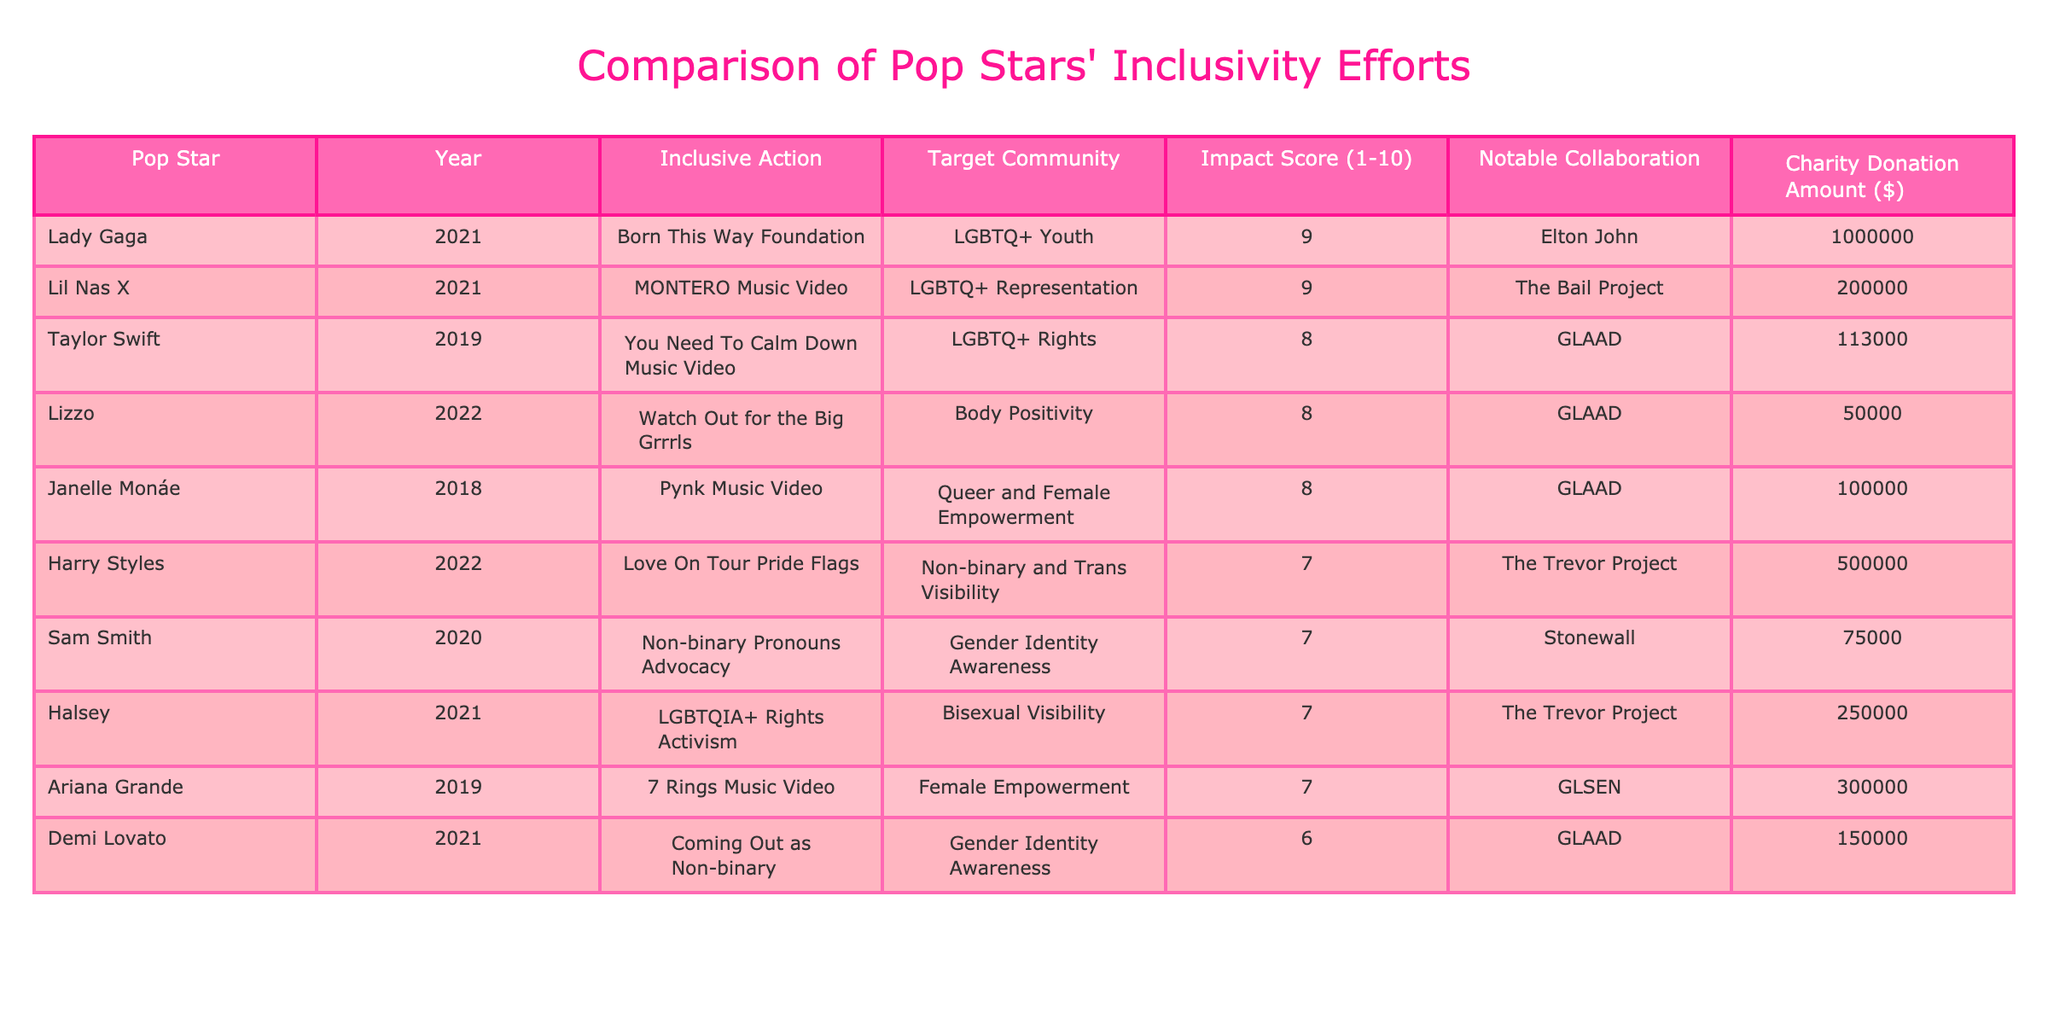What is the highest impact score listed in the table? The table shows various impact scores for different pop stars. By scanning the Impact Score column, I find that the highest score is 9, which is associated with both Lady Gaga and Lil Nas X's efforts.
Answer: 9 Which pop star collaborated with Elton John? Looking at the Notable Collaboration column, I can see that Lady Gaga is the only pop star listed that collaborated with Elton John.
Answer: Lady Gaga How many pop stars have an impact score of 8? By reviewing the Impact Score column, I find that there are three pop stars (Taylor Swift, Lizzo, and Janelle Monáe) who have a score of 8.
Answer: 3 What is the total amount donated to charity by all the pop stars listed? To determine the total, I add the charity donation amounts: 1,000,000 + 113,000 + 500,000 + 200,000 + 50,000 + 75,000 + 100,000 + 250,000 + 150,000 + 300,000. This calculation results in a total of 2,538,000.
Answer: 2538000 Did any of the pop stars focus their efforts on gender identity awareness? Reviewing the Inclusive Action and Target Community columns, I see that both Sam Smith and Demi Lovato's efforts were explicitly focused on gender identity awareness. Thus, the answer is yes.
Answer: Yes Which inclusive action was associated with the highest charity donation amount? In the Charity Donation Amount column, the highest value is 1,000,000, linked to Lady Gaga's action in 2021. This shows her significant commitment to the cause.
Answer: Lady Gaga's action Among the pop stars listed, who had the lowest impact score? By examining the Impact Score column, I can see that Demi Lovato has the lowest score at 6, indicating a comparatively less impactful action in terms of inclusivity efforts.
Answer: Demi Lovato What is the average impact score of the pop stars listed in the table? To find the average, I sum up all the impact scores: 9 (Lady Gaga) + 8 (Taylor Swift) + 7 (Harry Styles) + 9 (Lil Nas X) + 8 (Lizzo) + 7 (Sam Smith) + 8 (Janelle Monáe) + 7 (Halsey) + 6 (Demi Lovato) + 7 (Ariana Grande) = 78, and then divide by the number of pop stars (10). The average impact score is 78/10 = 7.8.
Answer: 7.8 Which pop star worked on LGBTQ+ rights and what was their notable collaboration? Scanning the Target Community and Notable Collaboration columns, Taylor Swift is the pop star who worked on LGBTQ+ rights, with a notable collaboration with GLAAD.
Answer: Taylor Swift with GLAAD 